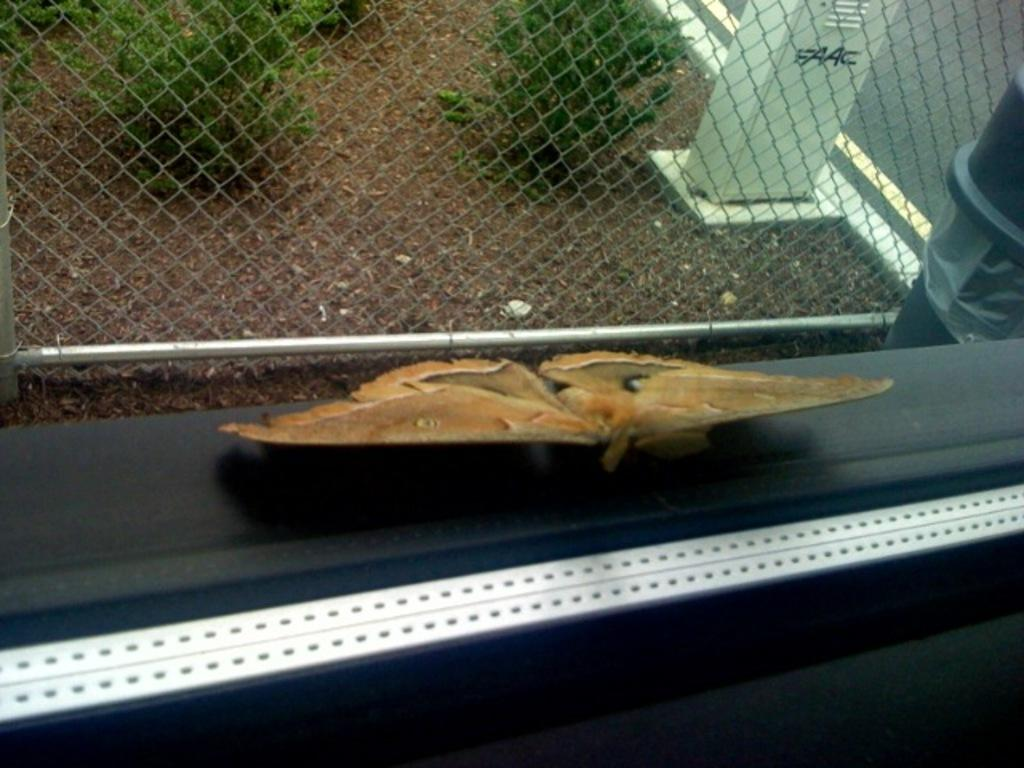What type of animal can be seen near the window frame in the image? There is a butterfly near the window frame in the image. What other living organisms are present in the image? There are plants in the image. What type of barrier is visible in the image? There is a wire fence in the image. What type of pathway is visible in the image? There is a road in the image. What type of structure is present in the image? There is a white box with a door in the image. What type of recess is visible in the image? There is no recess present in the image. Is the butterfly's brother also visible in the image? Butterflies do not have brothers, and there is no other animal mentioned in the image. 